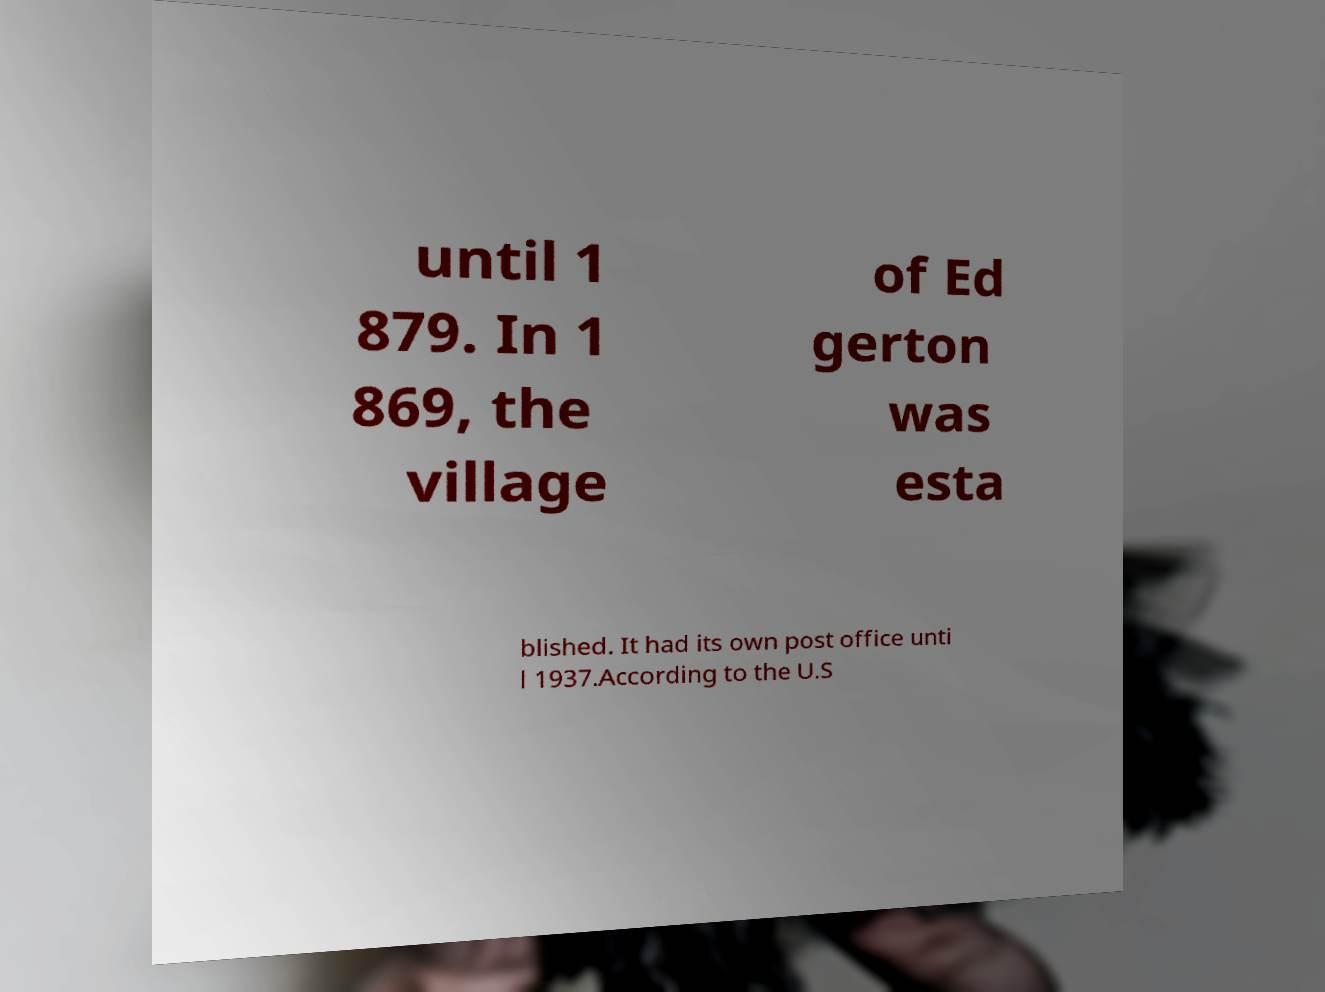Could you extract and type out the text from this image? until 1 879. In 1 869, the village of Ed gerton was esta blished. It had its own post office unti l 1937.According to the U.S 